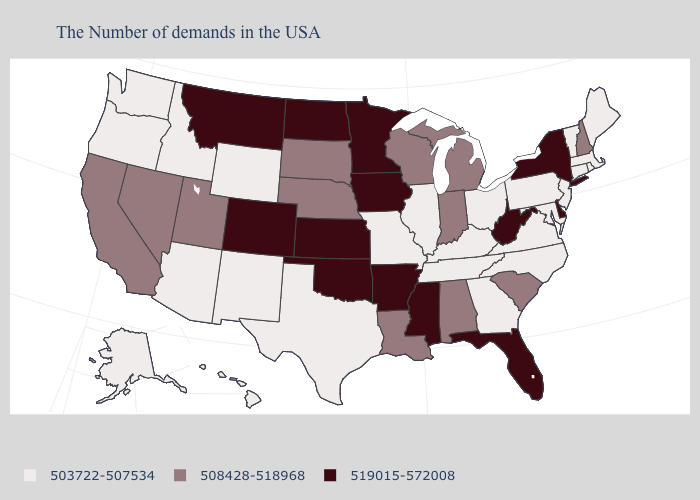Name the states that have a value in the range 519015-572008?
Answer briefly. New York, Delaware, West Virginia, Florida, Mississippi, Arkansas, Minnesota, Iowa, Kansas, Oklahoma, North Dakota, Colorado, Montana. Does the map have missing data?
Keep it brief. No. Is the legend a continuous bar?
Keep it brief. No. What is the value of New Hampshire?
Concise answer only. 508428-518968. What is the lowest value in states that border Iowa?
Concise answer only. 503722-507534. What is the lowest value in states that border Pennsylvania?
Give a very brief answer. 503722-507534. What is the value of Missouri?
Concise answer only. 503722-507534. Name the states that have a value in the range 519015-572008?
Be succinct. New York, Delaware, West Virginia, Florida, Mississippi, Arkansas, Minnesota, Iowa, Kansas, Oklahoma, North Dakota, Colorado, Montana. How many symbols are there in the legend?
Give a very brief answer. 3. What is the value of Kansas?
Give a very brief answer. 519015-572008. Name the states that have a value in the range 503722-507534?
Concise answer only. Maine, Massachusetts, Rhode Island, Vermont, Connecticut, New Jersey, Maryland, Pennsylvania, Virginia, North Carolina, Ohio, Georgia, Kentucky, Tennessee, Illinois, Missouri, Texas, Wyoming, New Mexico, Arizona, Idaho, Washington, Oregon, Alaska, Hawaii. Does Indiana have the lowest value in the MidWest?
Be succinct. No. Does Indiana have the lowest value in the USA?
Concise answer only. No. What is the value of Washington?
Write a very short answer. 503722-507534. 